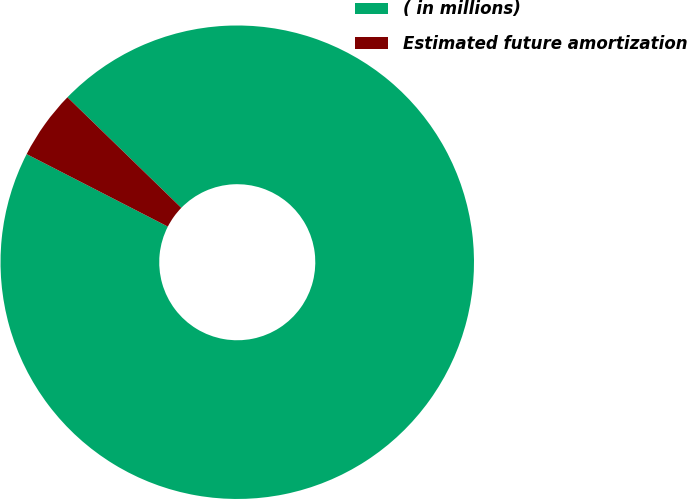<chart> <loc_0><loc_0><loc_500><loc_500><pie_chart><fcel>( in millions)<fcel>Estimated future amortization<nl><fcel>95.28%<fcel>4.72%<nl></chart> 